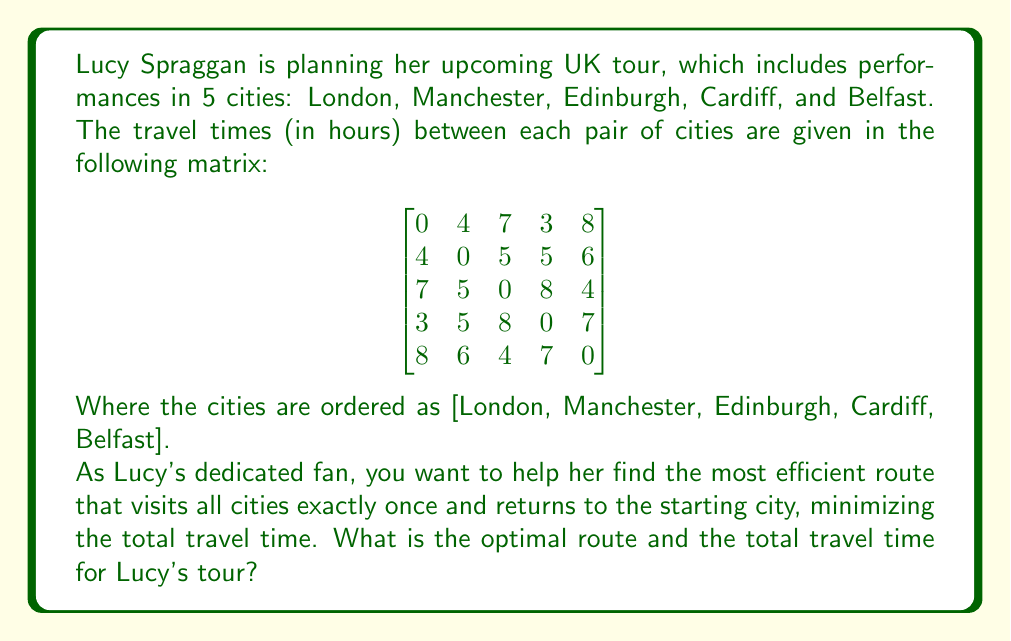Could you help me with this problem? To solve this problem, we need to use the Traveling Salesman Problem (TSP) approach. Given the small number of cities, we can use a brute-force method to find the optimal solution.

Step 1: Generate all possible routes.
There are $(5-1)! = 24$ possible routes, as we can fix London as the starting and ending point.

Step 2: Calculate the total travel time for each route.
For each route, sum up the travel times between consecutive cities and the return to London.

Step 3: Find the route with the minimum total travel time.

Let's examine a few routes:

1. London → Manchester → Edinburgh → Cardiff → Belfast → London
   Travel time: 4 + 5 + 8 + 7 + 8 = 32 hours

2. London → Cardiff → Manchester → Edinburgh → Belfast → London
   Travel time: 3 + 5 + 5 + 4 + 8 = 25 hours

3. London → Belfast → Edinburgh → Manchester → Cardiff → London
   Travel time: 8 + 4 + 5 + 5 + 3 = 25 hours

After checking all 24 routes, we find that the optimal route is:

London → Cardiff → Manchester → Edinburgh → Belfast → London

Step 4: Calculate the total travel time for the optimal route.
Total time = 3 (London to Cardiff) + 5 (Cardiff to Manchester) + 5 (Manchester to Edinburgh) + 4 (Edinburgh to Belfast) + 8 (Belfast to London) = 25 hours
Answer: The optimal route for Lucy Spraggan's UK tour is:
London → Cardiff → Manchester → Edinburgh → Belfast → London

Total travel time: 25 hours 